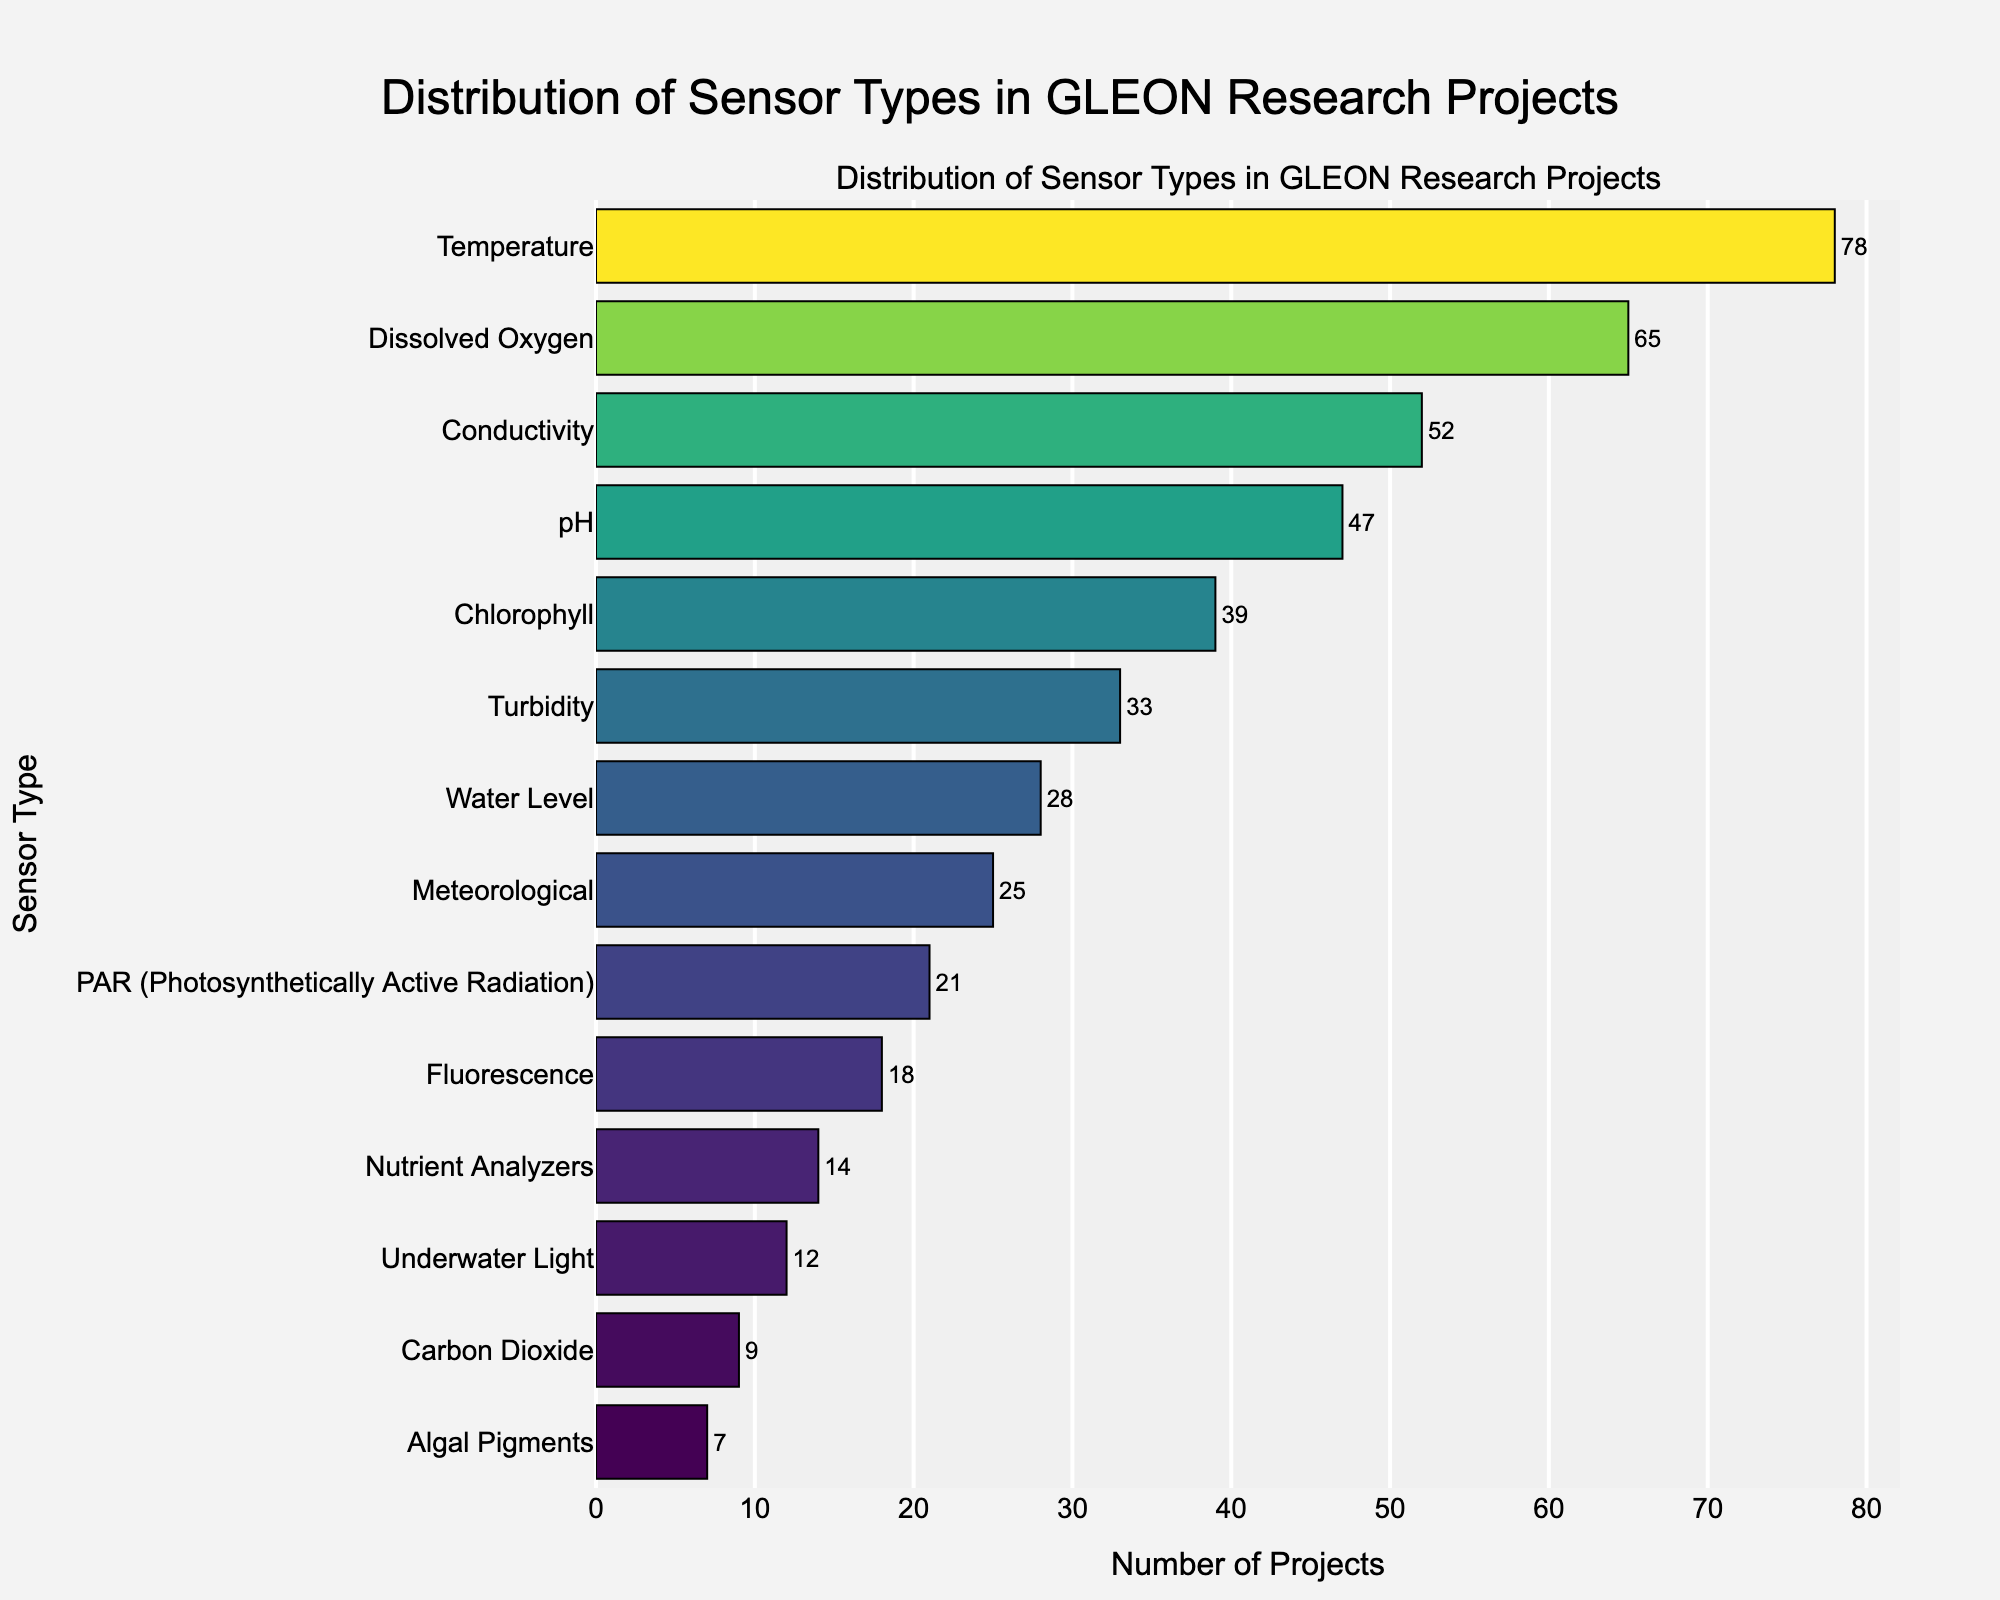what is the title of the figure? The title of the figure is written at the top of the plot, indicating the main topic or subject of the visual representation.
Answer: Distribution of Sensor Types in GLEON Research Projects How many sensor types are represented in the figure? Count the number of distinct sensors on the y-axis.
Answer: 14 Which sensor type is used in the highest number of projects? Look at the sensor type with the longest bar on the plot.
Answer: Temperature Which sensor type is used in the fewest number of projects? Identify the sensor type with the shortest bar on the plot.
Answer: Algal Pigments How many projects use Chlorophyll sensors? Find the length of the bar corresponding to Chlorophyll and read the value outside the bar.
Answer: 39 What is the difference in the number of projects between the most and least used sensor types? Find the values for the most (Temperature) and least (Algal Pigments) used sensors, then subtract the smaller from the larger. 78 (Temperature) - 7 (Algal Pigments) = 71.
Answer: 71 How many sensor types are used in 20 or fewer projects? Identify and count all bars that extend to a value of 20 or fewer on the x-axis.
Answer: 5 What is the total number of projects using Conductivity or pH sensors? Add the number of projects for Conductivity (52) and pH (47). 52 + 47 = 99.
Answer: 99 Which sensor type has almost the same number of projects as pH? Find the sensor type with a bar length close to the bar length of pH (47).
Answer: Conductivity (52) Are there more projects using Meteorological or Water Level sensors? Compare the values of the two sensor types by looking at the length of the bars. Water Level = 28, Meteorological = 25; Water Level has more.
Answer: Water Level 